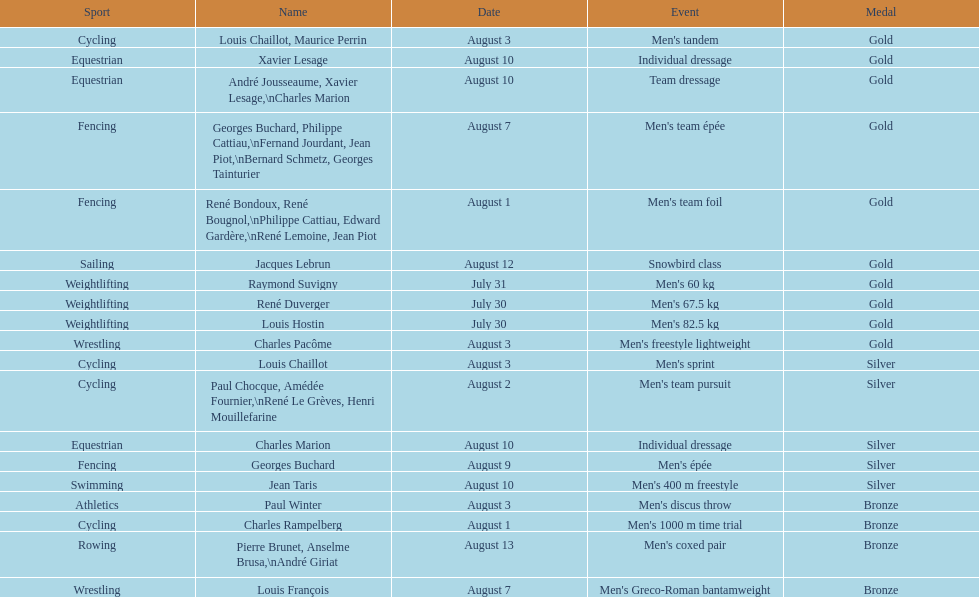What event is listed right before team dressage? Individual dressage. 